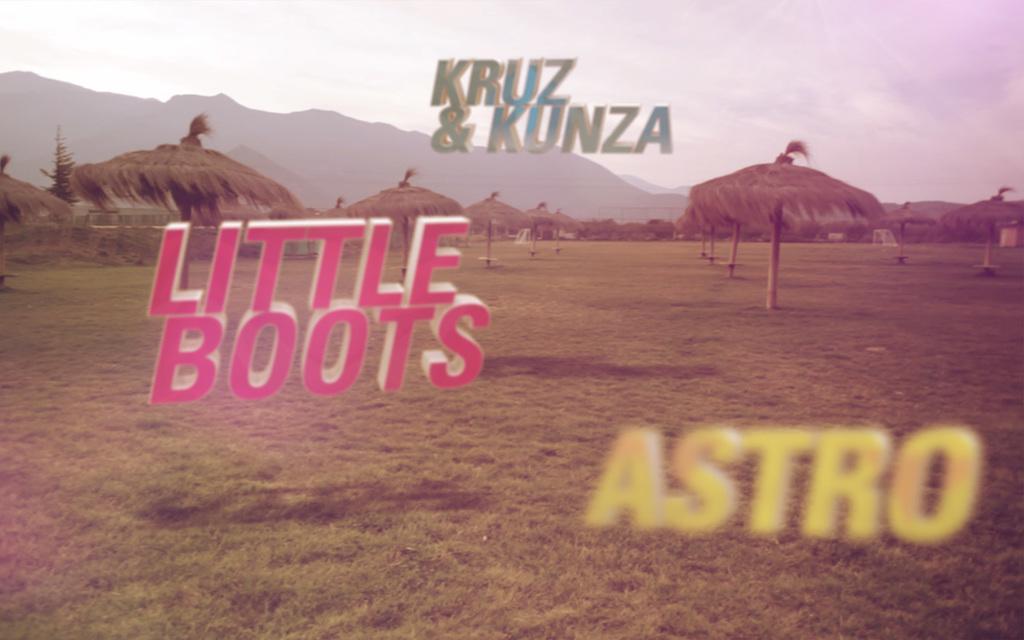Could you give a brief overview of what you see in this image? In the image we can see there is ground covered with grass and there are dry leaves tents kept on the ground. It's written ¨LITTLE BOOTS¨ and ¨ASTRO¨. Behind there are mountains and there is a clear sky. 